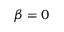<formula> <loc_0><loc_0><loc_500><loc_500>\beta = 0</formula> 